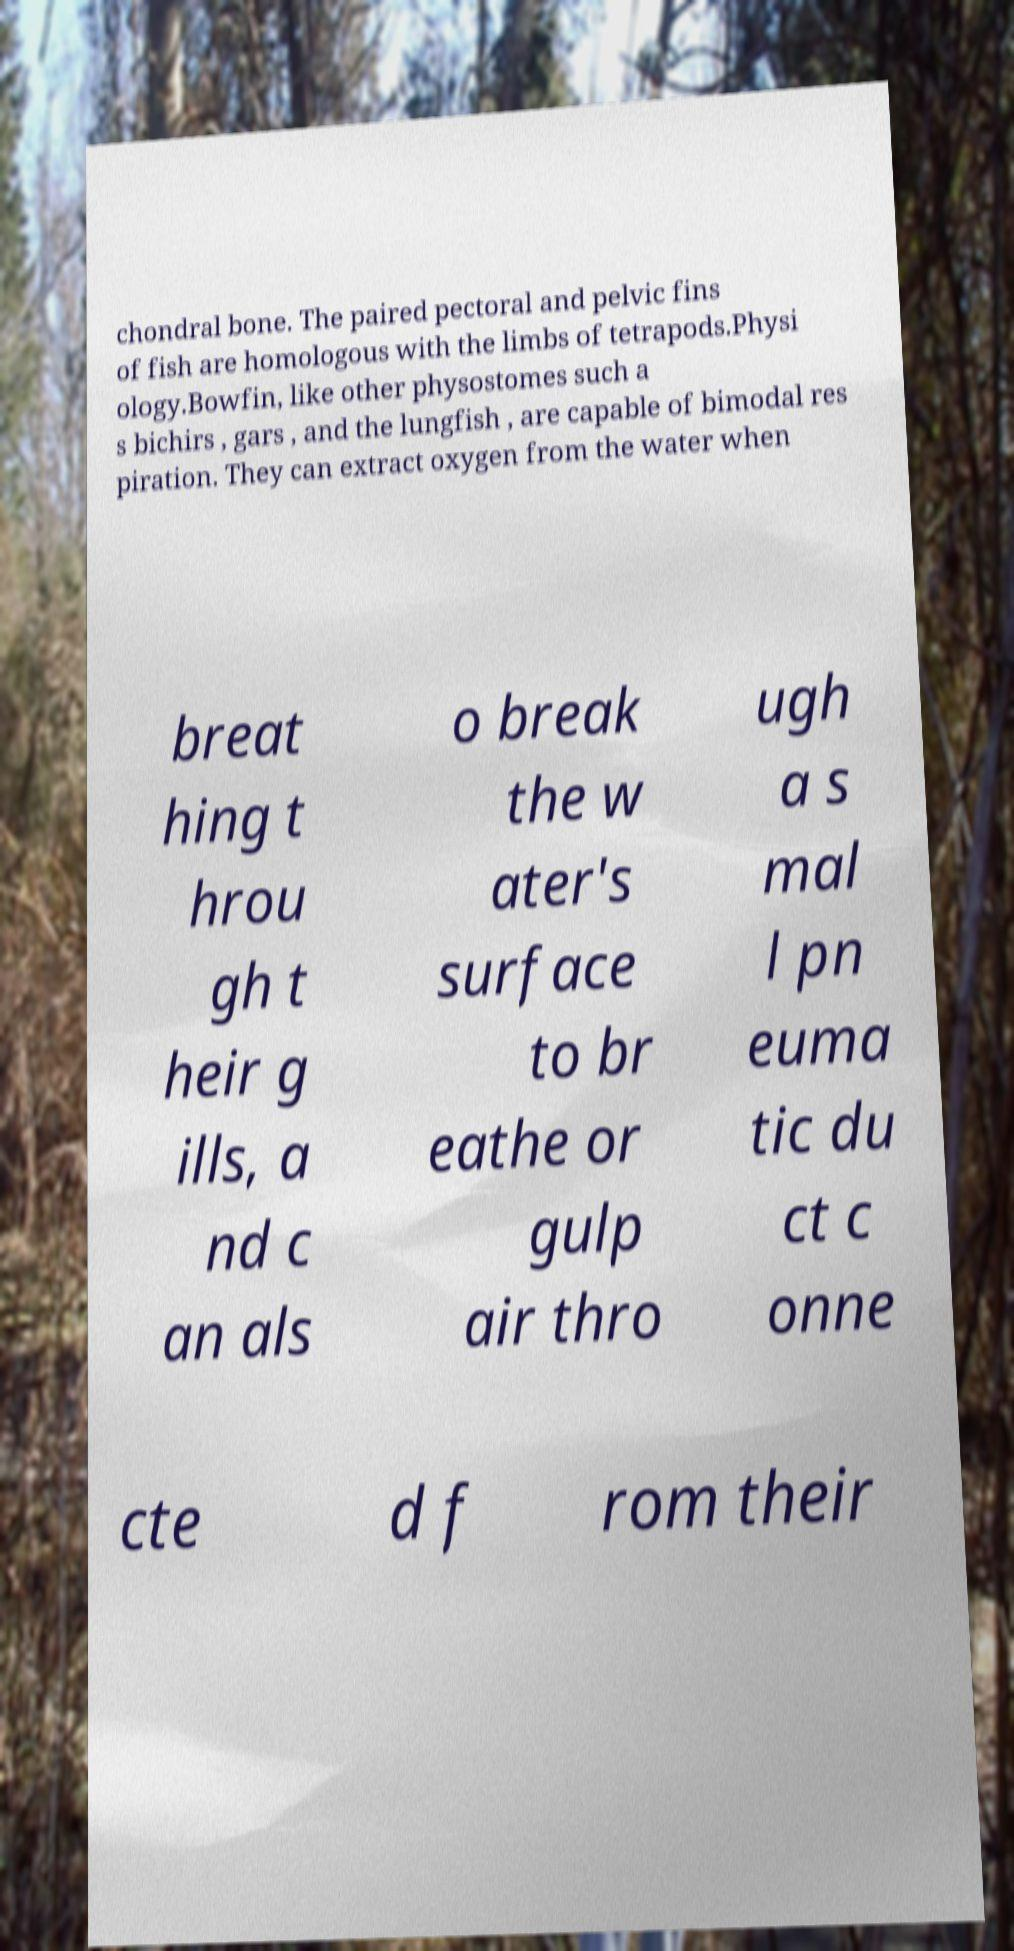Could you assist in decoding the text presented in this image and type it out clearly? chondral bone. The paired pectoral and pelvic fins of fish are homologous with the limbs of tetrapods.Physi ology.Bowfin, like other physostomes such a s bichirs , gars , and the lungfish , are capable of bimodal res piration. They can extract oxygen from the water when breat hing t hrou gh t heir g ills, a nd c an als o break the w ater's surface to br eathe or gulp air thro ugh a s mal l pn euma tic du ct c onne cte d f rom their 